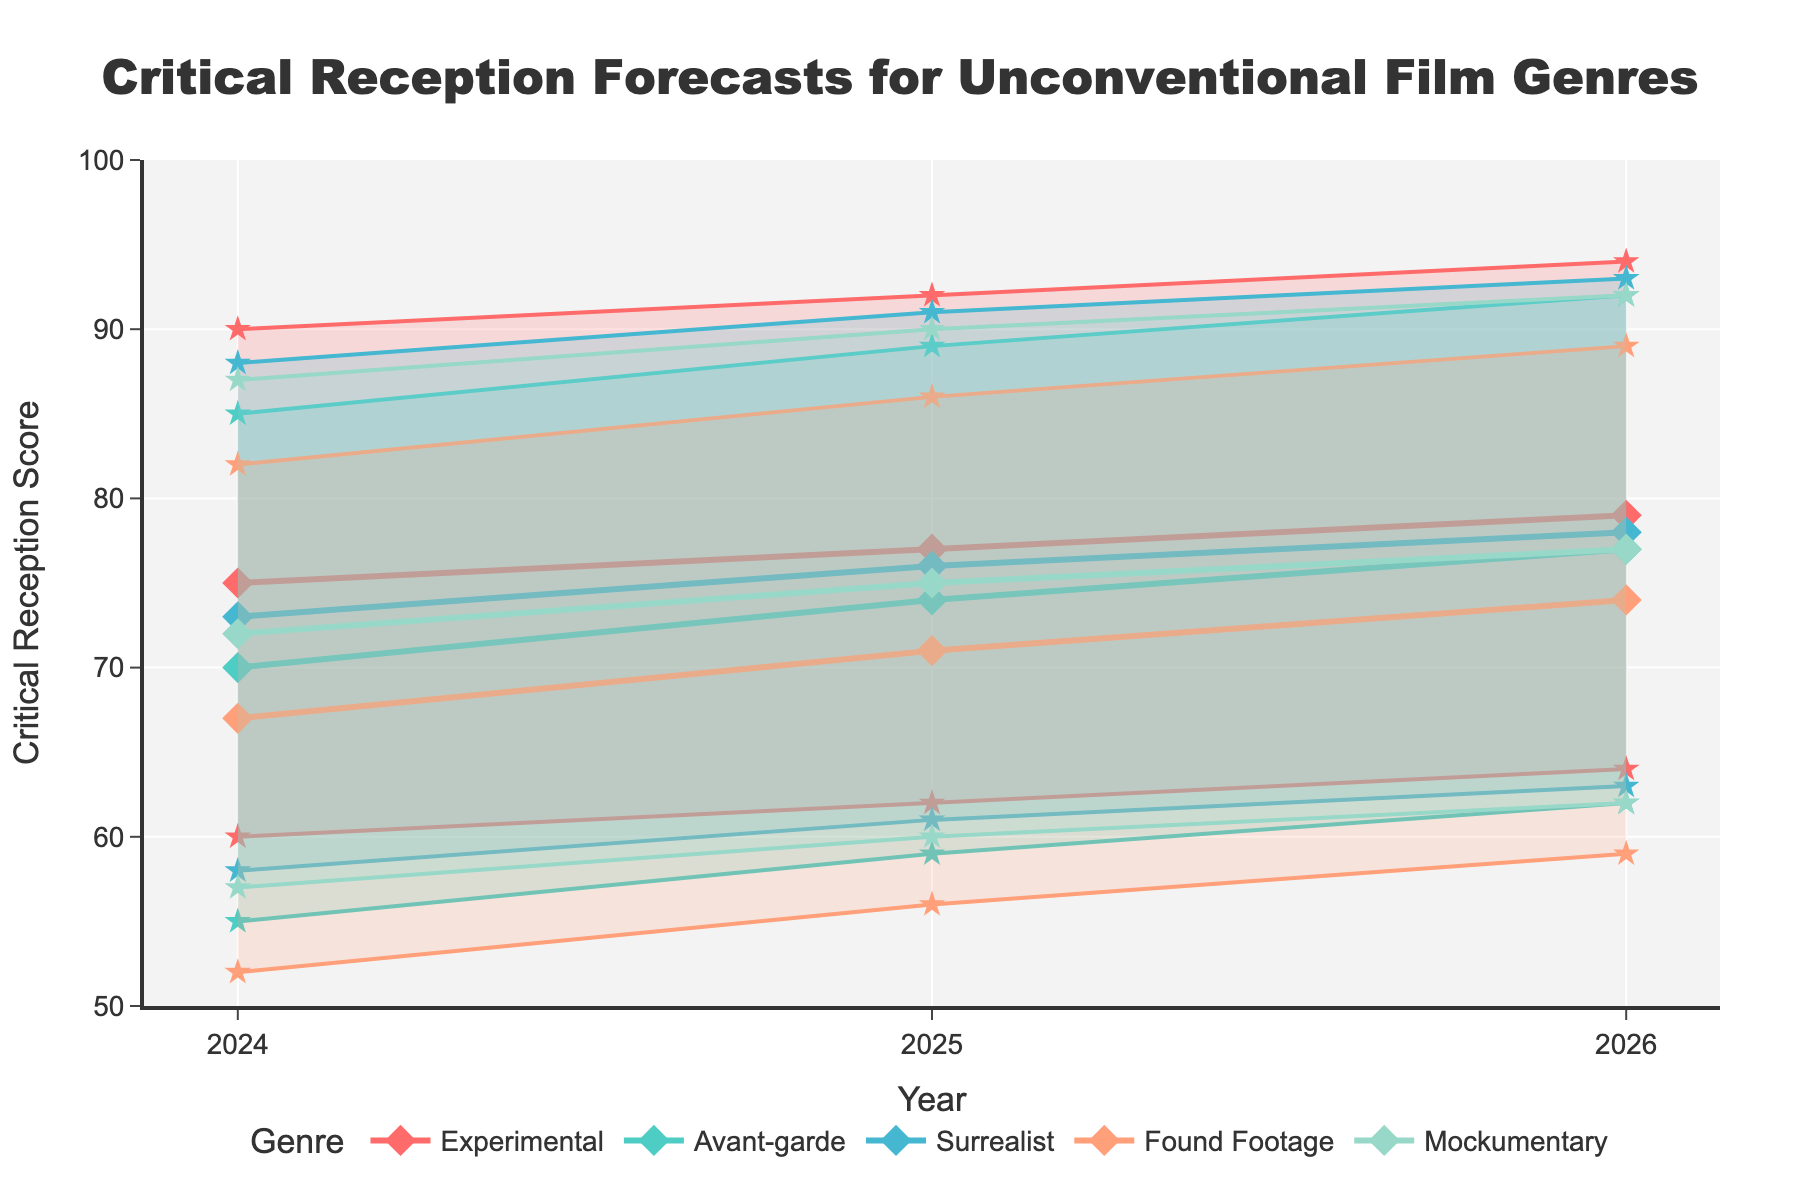What is the title of the plot? The title of the plot is written at the top of the figure, often in a larger and bold font to make it stand out.
Answer: Critical Reception Forecasts for Unconventional Film Genres Which genre is predicted to have the highest 'Best Case' reception score in 2026? By looking at the 'Best Case' line for each genre in the year 2026, the genre with the highest value can be identified.
Answer: Experimental In 2025, which genre has the narrowest range between 'Best Case' and 'Worst Case' reception scores? Calculate the difference between 'Best Case' and 'Worst Case' for each genre in 2025, and identify the smallest difference. Experimental: 30, Avant-garde: 30, Surrealist: 30, Found Footage: 30, Mockumentary: 30.
Answer: All genres have an equally narrowest range How does the 'Likely Case' reception score for Surrealist films change from 2024 to 2026? Compare the 'Likely Case' value for Surrealist films in 2024, 2025, and 2026. 2024: 73, 2025: 76, 2026: 78.
Answer: It increases Which year has the most significant increase in the 'Best Case' reception score for Found Footage films? Compare the 'Best Case' scores for Found Footage films across the years 2024, 2025, and 2026 to find the largest increment. 2025-2024: 86-82 = 4, 2026-2025: 89-86 = 3.
Answer: 2025 Which genre has the lowest expected (likely) reception score in 2026? Identify the 'Likely Case' values for all genres in 2026 and find the lowest value.
Answer: Found Footage What is the range of the 'Best Case' reception scores for Mockumentary films from 2024 to 2026? Identify the 'Best Case' values for Mockumentary films in 2024, 2025, and 2026, then find the range (highest value minus lowest value). 94-87=7.
Answer: 7 Between Avant-garde and Surrealist genres, which has a higher 'Worst Case' score in 2025, and what is the difference? Compare the 'Worst Case' values for Avant-garde and Surrealist genres in 2025. Avant-garde: 59, Surrealist: 61. Calculate the difference (61-59=2).
Answer: Surrealist by 2 points Which genre shows the most consistent likely reception score from 2024 to 2026? Examine the 'Likely Case' scores for each genre over the years and identify which genre's scores change the least. Experimental: 75, 77, 79; Avant-garde: 70, 74, 77; Surrealist: 73, 76, 78; Found Footage: 67, 71, 74; Mockumentary: 72, 75, 77.
Answer: Mockumentary 